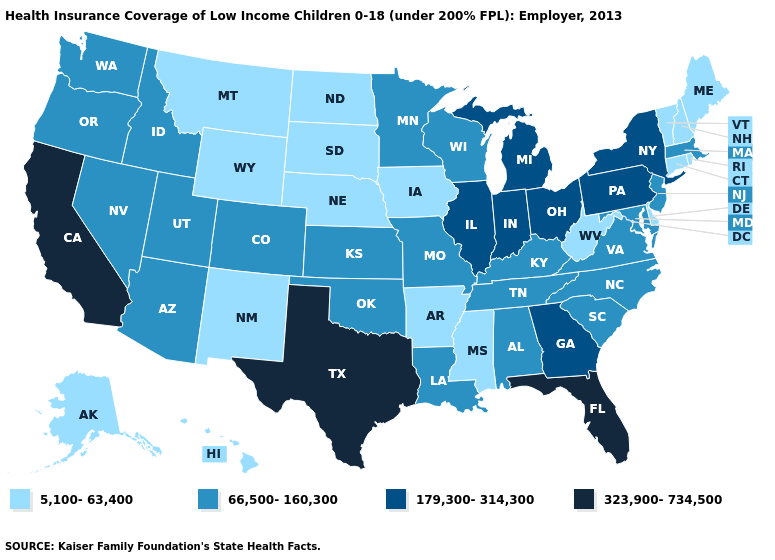Does South Dakota have the same value as California?
Concise answer only. No. Name the states that have a value in the range 66,500-160,300?
Short answer required. Alabama, Arizona, Colorado, Idaho, Kansas, Kentucky, Louisiana, Maryland, Massachusetts, Minnesota, Missouri, Nevada, New Jersey, North Carolina, Oklahoma, Oregon, South Carolina, Tennessee, Utah, Virginia, Washington, Wisconsin. Does the map have missing data?
Give a very brief answer. No. Which states hav the highest value in the Northeast?
Write a very short answer. New York, Pennsylvania. Which states have the lowest value in the Northeast?
Answer briefly. Connecticut, Maine, New Hampshire, Rhode Island, Vermont. Among the states that border Utah , which have the lowest value?
Give a very brief answer. New Mexico, Wyoming. What is the value of Idaho?
Keep it brief. 66,500-160,300. Name the states that have a value in the range 179,300-314,300?
Answer briefly. Georgia, Illinois, Indiana, Michigan, New York, Ohio, Pennsylvania. Which states have the highest value in the USA?
Concise answer only. California, Florida, Texas. Which states have the lowest value in the MidWest?
Quick response, please. Iowa, Nebraska, North Dakota, South Dakota. Is the legend a continuous bar?
Quick response, please. No. What is the value of South Dakota?
Quick response, please. 5,100-63,400. Name the states that have a value in the range 323,900-734,500?
Quick response, please. California, Florida, Texas. What is the value of Massachusetts?
Short answer required. 66,500-160,300. What is the value of Oregon?
Concise answer only. 66,500-160,300. 